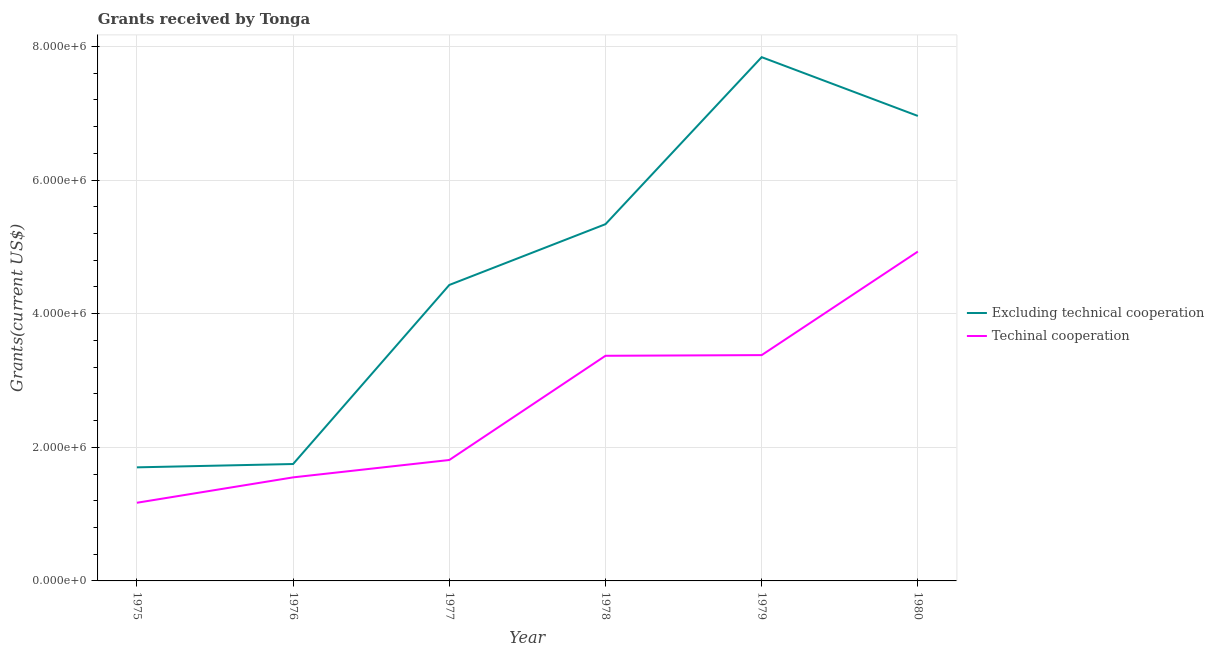How many different coloured lines are there?
Offer a terse response. 2. Does the line corresponding to amount of grants received(excluding technical cooperation) intersect with the line corresponding to amount of grants received(including technical cooperation)?
Keep it short and to the point. No. What is the amount of grants received(excluding technical cooperation) in 1978?
Provide a short and direct response. 5.34e+06. Across all years, what is the maximum amount of grants received(excluding technical cooperation)?
Make the answer very short. 7.84e+06. Across all years, what is the minimum amount of grants received(including technical cooperation)?
Offer a very short reply. 1.17e+06. In which year was the amount of grants received(excluding technical cooperation) maximum?
Make the answer very short. 1979. In which year was the amount of grants received(including technical cooperation) minimum?
Make the answer very short. 1975. What is the total amount of grants received(including technical cooperation) in the graph?
Your answer should be compact. 1.62e+07. What is the difference between the amount of grants received(including technical cooperation) in 1975 and that in 1979?
Keep it short and to the point. -2.21e+06. What is the difference between the amount of grants received(excluding technical cooperation) in 1980 and the amount of grants received(including technical cooperation) in 1977?
Ensure brevity in your answer.  5.15e+06. What is the average amount of grants received(excluding technical cooperation) per year?
Give a very brief answer. 4.67e+06. In the year 1979, what is the difference between the amount of grants received(including technical cooperation) and amount of grants received(excluding technical cooperation)?
Keep it short and to the point. -4.46e+06. In how many years, is the amount of grants received(including technical cooperation) greater than 5200000 US$?
Your answer should be compact. 0. What is the ratio of the amount of grants received(excluding technical cooperation) in 1976 to that in 1979?
Your response must be concise. 0.22. What is the difference between the highest and the second highest amount of grants received(including technical cooperation)?
Give a very brief answer. 1.55e+06. What is the difference between the highest and the lowest amount of grants received(including technical cooperation)?
Make the answer very short. 3.76e+06. In how many years, is the amount of grants received(excluding technical cooperation) greater than the average amount of grants received(excluding technical cooperation) taken over all years?
Keep it short and to the point. 3. Is the amount of grants received(excluding technical cooperation) strictly less than the amount of grants received(including technical cooperation) over the years?
Keep it short and to the point. No. How many lines are there?
Keep it short and to the point. 2. How many years are there in the graph?
Your answer should be compact. 6. What is the difference between two consecutive major ticks on the Y-axis?
Make the answer very short. 2.00e+06. Does the graph contain grids?
Ensure brevity in your answer.  Yes. Where does the legend appear in the graph?
Make the answer very short. Center right. How many legend labels are there?
Offer a very short reply. 2. How are the legend labels stacked?
Offer a terse response. Vertical. What is the title of the graph?
Provide a short and direct response. Grants received by Tonga. Does "Private consumption" appear as one of the legend labels in the graph?
Your answer should be compact. No. What is the label or title of the Y-axis?
Make the answer very short. Grants(current US$). What is the Grants(current US$) in Excluding technical cooperation in 1975?
Give a very brief answer. 1.70e+06. What is the Grants(current US$) of Techinal cooperation in 1975?
Ensure brevity in your answer.  1.17e+06. What is the Grants(current US$) in Excluding technical cooperation in 1976?
Offer a very short reply. 1.75e+06. What is the Grants(current US$) in Techinal cooperation in 1976?
Make the answer very short. 1.55e+06. What is the Grants(current US$) of Excluding technical cooperation in 1977?
Your answer should be very brief. 4.43e+06. What is the Grants(current US$) in Techinal cooperation in 1977?
Offer a terse response. 1.81e+06. What is the Grants(current US$) in Excluding technical cooperation in 1978?
Your response must be concise. 5.34e+06. What is the Grants(current US$) in Techinal cooperation in 1978?
Ensure brevity in your answer.  3.37e+06. What is the Grants(current US$) in Excluding technical cooperation in 1979?
Offer a terse response. 7.84e+06. What is the Grants(current US$) of Techinal cooperation in 1979?
Your answer should be compact. 3.38e+06. What is the Grants(current US$) of Excluding technical cooperation in 1980?
Your response must be concise. 6.96e+06. What is the Grants(current US$) of Techinal cooperation in 1980?
Your answer should be very brief. 4.93e+06. Across all years, what is the maximum Grants(current US$) of Excluding technical cooperation?
Provide a succinct answer. 7.84e+06. Across all years, what is the maximum Grants(current US$) of Techinal cooperation?
Ensure brevity in your answer.  4.93e+06. Across all years, what is the minimum Grants(current US$) of Excluding technical cooperation?
Offer a terse response. 1.70e+06. Across all years, what is the minimum Grants(current US$) of Techinal cooperation?
Provide a short and direct response. 1.17e+06. What is the total Grants(current US$) in Excluding technical cooperation in the graph?
Give a very brief answer. 2.80e+07. What is the total Grants(current US$) in Techinal cooperation in the graph?
Make the answer very short. 1.62e+07. What is the difference between the Grants(current US$) of Techinal cooperation in 1975 and that in 1976?
Make the answer very short. -3.80e+05. What is the difference between the Grants(current US$) in Excluding technical cooperation in 1975 and that in 1977?
Provide a succinct answer. -2.73e+06. What is the difference between the Grants(current US$) of Techinal cooperation in 1975 and that in 1977?
Offer a very short reply. -6.40e+05. What is the difference between the Grants(current US$) in Excluding technical cooperation in 1975 and that in 1978?
Offer a terse response. -3.64e+06. What is the difference between the Grants(current US$) of Techinal cooperation in 1975 and that in 1978?
Provide a short and direct response. -2.20e+06. What is the difference between the Grants(current US$) in Excluding technical cooperation in 1975 and that in 1979?
Ensure brevity in your answer.  -6.14e+06. What is the difference between the Grants(current US$) of Techinal cooperation in 1975 and that in 1979?
Give a very brief answer. -2.21e+06. What is the difference between the Grants(current US$) of Excluding technical cooperation in 1975 and that in 1980?
Keep it short and to the point. -5.26e+06. What is the difference between the Grants(current US$) in Techinal cooperation in 1975 and that in 1980?
Your response must be concise. -3.76e+06. What is the difference between the Grants(current US$) of Excluding technical cooperation in 1976 and that in 1977?
Your answer should be very brief. -2.68e+06. What is the difference between the Grants(current US$) of Techinal cooperation in 1976 and that in 1977?
Ensure brevity in your answer.  -2.60e+05. What is the difference between the Grants(current US$) of Excluding technical cooperation in 1976 and that in 1978?
Ensure brevity in your answer.  -3.59e+06. What is the difference between the Grants(current US$) in Techinal cooperation in 1976 and that in 1978?
Your response must be concise. -1.82e+06. What is the difference between the Grants(current US$) in Excluding technical cooperation in 1976 and that in 1979?
Provide a succinct answer. -6.09e+06. What is the difference between the Grants(current US$) in Techinal cooperation in 1976 and that in 1979?
Ensure brevity in your answer.  -1.83e+06. What is the difference between the Grants(current US$) in Excluding technical cooperation in 1976 and that in 1980?
Your response must be concise. -5.21e+06. What is the difference between the Grants(current US$) in Techinal cooperation in 1976 and that in 1980?
Your answer should be compact. -3.38e+06. What is the difference between the Grants(current US$) in Excluding technical cooperation in 1977 and that in 1978?
Your response must be concise. -9.10e+05. What is the difference between the Grants(current US$) of Techinal cooperation in 1977 and that in 1978?
Provide a short and direct response. -1.56e+06. What is the difference between the Grants(current US$) of Excluding technical cooperation in 1977 and that in 1979?
Offer a very short reply. -3.41e+06. What is the difference between the Grants(current US$) in Techinal cooperation in 1977 and that in 1979?
Your answer should be very brief. -1.57e+06. What is the difference between the Grants(current US$) in Excluding technical cooperation in 1977 and that in 1980?
Offer a very short reply. -2.53e+06. What is the difference between the Grants(current US$) in Techinal cooperation in 1977 and that in 1980?
Your answer should be compact. -3.12e+06. What is the difference between the Grants(current US$) of Excluding technical cooperation in 1978 and that in 1979?
Offer a very short reply. -2.50e+06. What is the difference between the Grants(current US$) of Excluding technical cooperation in 1978 and that in 1980?
Provide a succinct answer. -1.62e+06. What is the difference between the Grants(current US$) of Techinal cooperation in 1978 and that in 1980?
Provide a succinct answer. -1.56e+06. What is the difference between the Grants(current US$) in Excluding technical cooperation in 1979 and that in 1980?
Make the answer very short. 8.80e+05. What is the difference between the Grants(current US$) of Techinal cooperation in 1979 and that in 1980?
Your response must be concise. -1.55e+06. What is the difference between the Grants(current US$) in Excluding technical cooperation in 1975 and the Grants(current US$) in Techinal cooperation in 1976?
Your answer should be compact. 1.50e+05. What is the difference between the Grants(current US$) of Excluding technical cooperation in 1975 and the Grants(current US$) of Techinal cooperation in 1978?
Offer a very short reply. -1.67e+06. What is the difference between the Grants(current US$) of Excluding technical cooperation in 1975 and the Grants(current US$) of Techinal cooperation in 1979?
Your answer should be compact. -1.68e+06. What is the difference between the Grants(current US$) in Excluding technical cooperation in 1975 and the Grants(current US$) in Techinal cooperation in 1980?
Provide a succinct answer. -3.23e+06. What is the difference between the Grants(current US$) in Excluding technical cooperation in 1976 and the Grants(current US$) in Techinal cooperation in 1978?
Your answer should be very brief. -1.62e+06. What is the difference between the Grants(current US$) in Excluding technical cooperation in 1976 and the Grants(current US$) in Techinal cooperation in 1979?
Your response must be concise. -1.63e+06. What is the difference between the Grants(current US$) of Excluding technical cooperation in 1976 and the Grants(current US$) of Techinal cooperation in 1980?
Your answer should be very brief. -3.18e+06. What is the difference between the Grants(current US$) of Excluding technical cooperation in 1977 and the Grants(current US$) of Techinal cooperation in 1978?
Keep it short and to the point. 1.06e+06. What is the difference between the Grants(current US$) in Excluding technical cooperation in 1977 and the Grants(current US$) in Techinal cooperation in 1979?
Offer a terse response. 1.05e+06. What is the difference between the Grants(current US$) of Excluding technical cooperation in 1977 and the Grants(current US$) of Techinal cooperation in 1980?
Provide a succinct answer. -5.00e+05. What is the difference between the Grants(current US$) of Excluding technical cooperation in 1978 and the Grants(current US$) of Techinal cooperation in 1979?
Keep it short and to the point. 1.96e+06. What is the difference between the Grants(current US$) of Excluding technical cooperation in 1979 and the Grants(current US$) of Techinal cooperation in 1980?
Make the answer very short. 2.91e+06. What is the average Grants(current US$) in Excluding technical cooperation per year?
Provide a succinct answer. 4.67e+06. What is the average Grants(current US$) in Techinal cooperation per year?
Provide a succinct answer. 2.70e+06. In the year 1975, what is the difference between the Grants(current US$) in Excluding technical cooperation and Grants(current US$) in Techinal cooperation?
Your answer should be very brief. 5.30e+05. In the year 1976, what is the difference between the Grants(current US$) of Excluding technical cooperation and Grants(current US$) of Techinal cooperation?
Your response must be concise. 2.00e+05. In the year 1977, what is the difference between the Grants(current US$) of Excluding technical cooperation and Grants(current US$) of Techinal cooperation?
Your response must be concise. 2.62e+06. In the year 1978, what is the difference between the Grants(current US$) in Excluding technical cooperation and Grants(current US$) in Techinal cooperation?
Ensure brevity in your answer.  1.97e+06. In the year 1979, what is the difference between the Grants(current US$) in Excluding technical cooperation and Grants(current US$) in Techinal cooperation?
Ensure brevity in your answer.  4.46e+06. In the year 1980, what is the difference between the Grants(current US$) of Excluding technical cooperation and Grants(current US$) of Techinal cooperation?
Provide a short and direct response. 2.03e+06. What is the ratio of the Grants(current US$) in Excluding technical cooperation in 1975 to that in 1976?
Give a very brief answer. 0.97. What is the ratio of the Grants(current US$) in Techinal cooperation in 1975 to that in 1976?
Make the answer very short. 0.75. What is the ratio of the Grants(current US$) of Excluding technical cooperation in 1975 to that in 1977?
Offer a very short reply. 0.38. What is the ratio of the Grants(current US$) of Techinal cooperation in 1975 to that in 1977?
Your answer should be compact. 0.65. What is the ratio of the Grants(current US$) in Excluding technical cooperation in 1975 to that in 1978?
Make the answer very short. 0.32. What is the ratio of the Grants(current US$) of Techinal cooperation in 1975 to that in 1978?
Provide a short and direct response. 0.35. What is the ratio of the Grants(current US$) in Excluding technical cooperation in 1975 to that in 1979?
Give a very brief answer. 0.22. What is the ratio of the Grants(current US$) in Techinal cooperation in 1975 to that in 1979?
Your response must be concise. 0.35. What is the ratio of the Grants(current US$) of Excluding technical cooperation in 1975 to that in 1980?
Offer a very short reply. 0.24. What is the ratio of the Grants(current US$) of Techinal cooperation in 1975 to that in 1980?
Offer a very short reply. 0.24. What is the ratio of the Grants(current US$) of Excluding technical cooperation in 1976 to that in 1977?
Your answer should be compact. 0.4. What is the ratio of the Grants(current US$) of Techinal cooperation in 1976 to that in 1977?
Make the answer very short. 0.86. What is the ratio of the Grants(current US$) in Excluding technical cooperation in 1976 to that in 1978?
Give a very brief answer. 0.33. What is the ratio of the Grants(current US$) in Techinal cooperation in 1976 to that in 1978?
Keep it short and to the point. 0.46. What is the ratio of the Grants(current US$) in Excluding technical cooperation in 1976 to that in 1979?
Offer a very short reply. 0.22. What is the ratio of the Grants(current US$) of Techinal cooperation in 1976 to that in 1979?
Make the answer very short. 0.46. What is the ratio of the Grants(current US$) in Excluding technical cooperation in 1976 to that in 1980?
Provide a succinct answer. 0.25. What is the ratio of the Grants(current US$) of Techinal cooperation in 1976 to that in 1980?
Provide a succinct answer. 0.31. What is the ratio of the Grants(current US$) in Excluding technical cooperation in 1977 to that in 1978?
Ensure brevity in your answer.  0.83. What is the ratio of the Grants(current US$) in Techinal cooperation in 1977 to that in 1978?
Give a very brief answer. 0.54. What is the ratio of the Grants(current US$) of Excluding technical cooperation in 1977 to that in 1979?
Offer a terse response. 0.57. What is the ratio of the Grants(current US$) in Techinal cooperation in 1977 to that in 1979?
Your answer should be compact. 0.54. What is the ratio of the Grants(current US$) of Excluding technical cooperation in 1977 to that in 1980?
Make the answer very short. 0.64. What is the ratio of the Grants(current US$) in Techinal cooperation in 1977 to that in 1980?
Your answer should be compact. 0.37. What is the ratio of the Grants(current US$) of Excluding technical cooperation in 1978 to that in 1979?
Keep it short and to the point. 0.68. What is the ratio of the Grants(current US$) of Excluding technical cooperation in 1978 to that in 1980?
Offer a very short reply. 0.77. What is the ratio of the Grants(current US$) of Techinal cooperation in 1978 to that in 1980?
Your answer should be compact. 0.68. What is the ratio of the Grants(current US$) in Excluding technical cooperation in 1979 to that in 1980?
Provide a short and direct response. 1.13. What is the ratio of the Grants(current US$) in Techinal cooperation in 1979 to that in 1980?
Your answer should be very brief. 0.69. What is the difference between the highest and the second highest Grants(current US$) of Excluding technical cooperation?
Offer a very short reply. 8.80e+05. What is the difference between the highest and the second highest Grants(current US$) of Techinal cooperation?
Keep it short and to the point. 1.55e+06. What is the difference between the highest and the lowest Grants(current US$) in Excluding technical cooperation?
Ensure brevity in your answer.  6.14e+06. What is the difference between the highest and the lowest Grants(current US$) in Techinal cooperation?
Provide a succinct answer. 3.76e+06. 